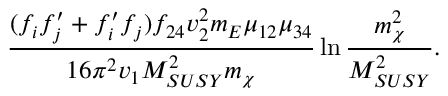<formula> <loc_0><loc_0><loc_500><loc_500>{ \frac { ( f _ { i } f _ { j } ^ { \prime } + f _ { i } ^ { \prime } f _ { j } ) f _ { 2 4 } v _ { 2 } ^ { 2 } m _ { E } \mu _ { 1 2 } \mu _ { 3 4 } } { 1 6 \pi ^ { 2 } v _ { 1 } M _ { S U S Y } ^ { 2 } m _ { \chi } } } \ln { \frac { m _ { \chi } ^ { 2 } } { M _ { S U S Y } ^ { 2 } } } .</formula> 